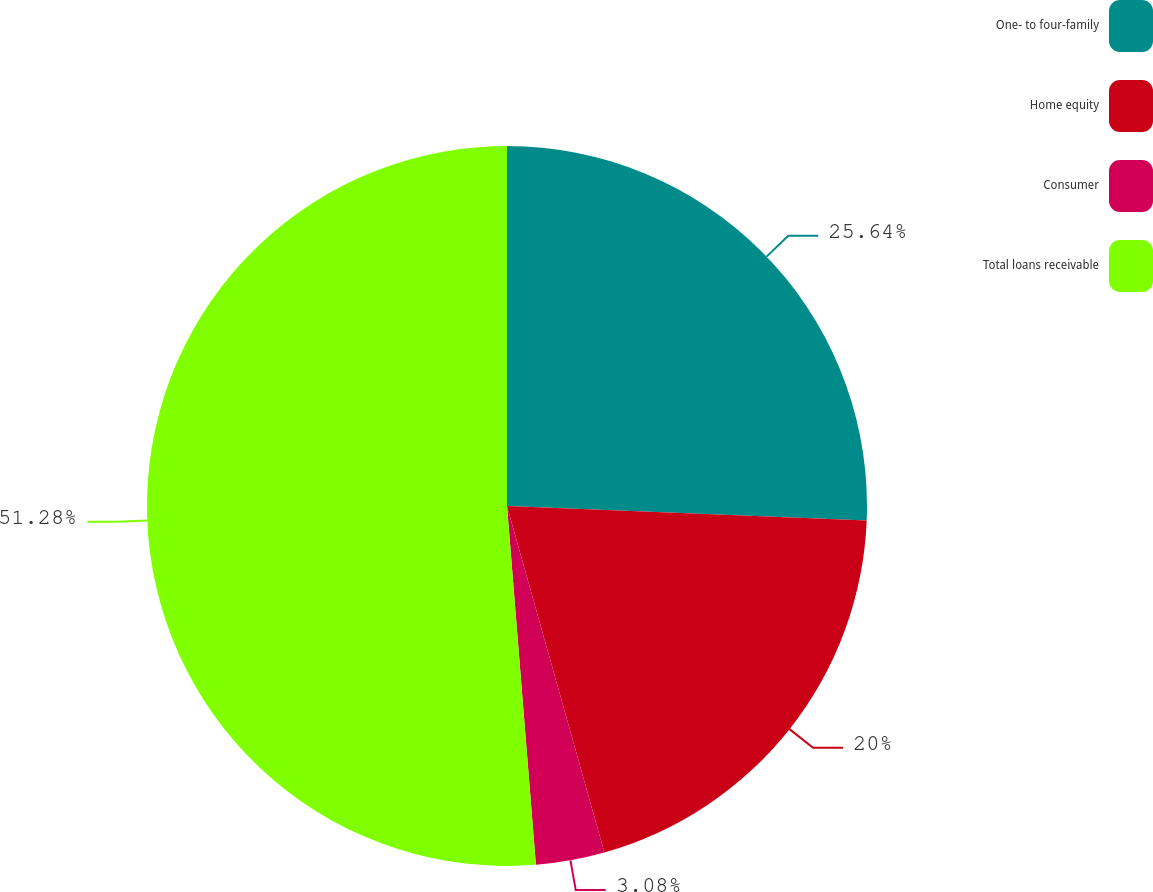Convert chart. <chart><loc_0><loc_0><loc_500><loc_500><pie_chart><fcel>One- to four-family<fcel>Home equity<fcel>Consumer<fcel>Total loans receivable<nl><fcel>25.64%<fcel>20.0%<fcel>3.08%<fcel>51.28%<nl></chart> 